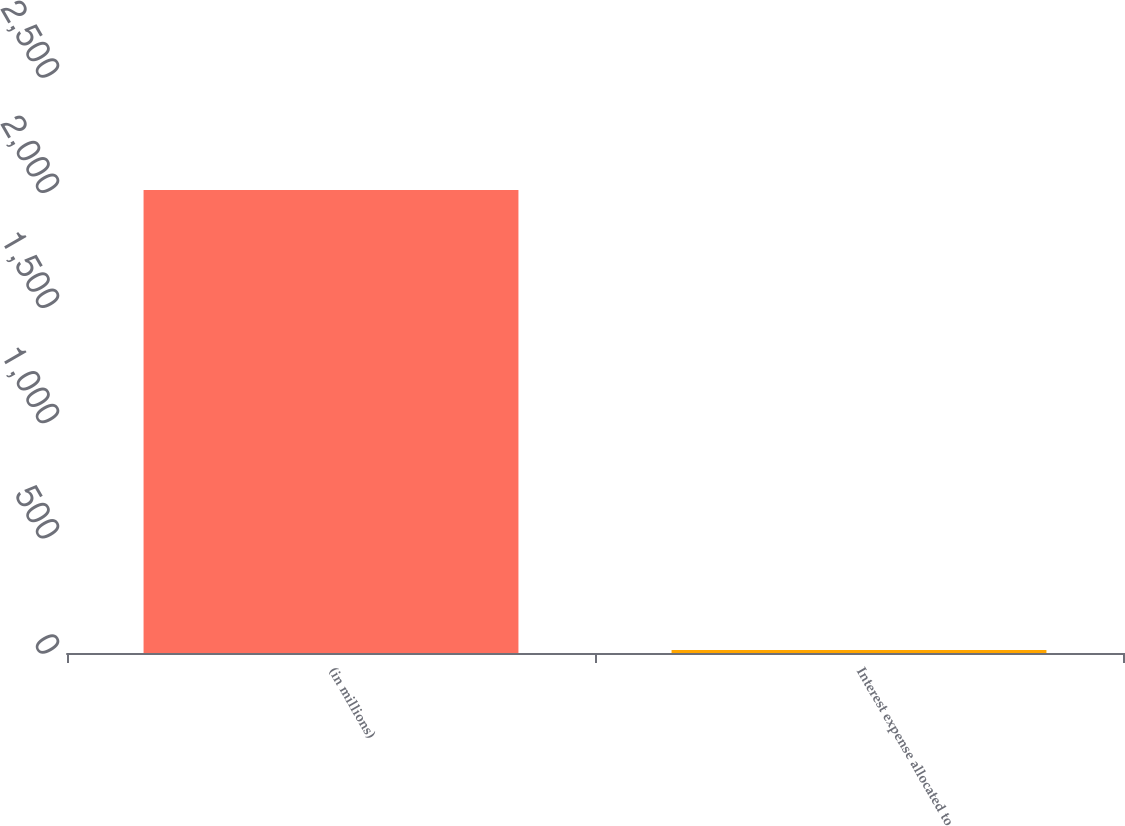Convert chart. <chart><loc_0><loc_0><loc_500><loc_500><bar_chart><fcel>(in millions)<fcel>Interest expense allocated to<nl><fcel>2010<fcel>12.8<nl></chart> 